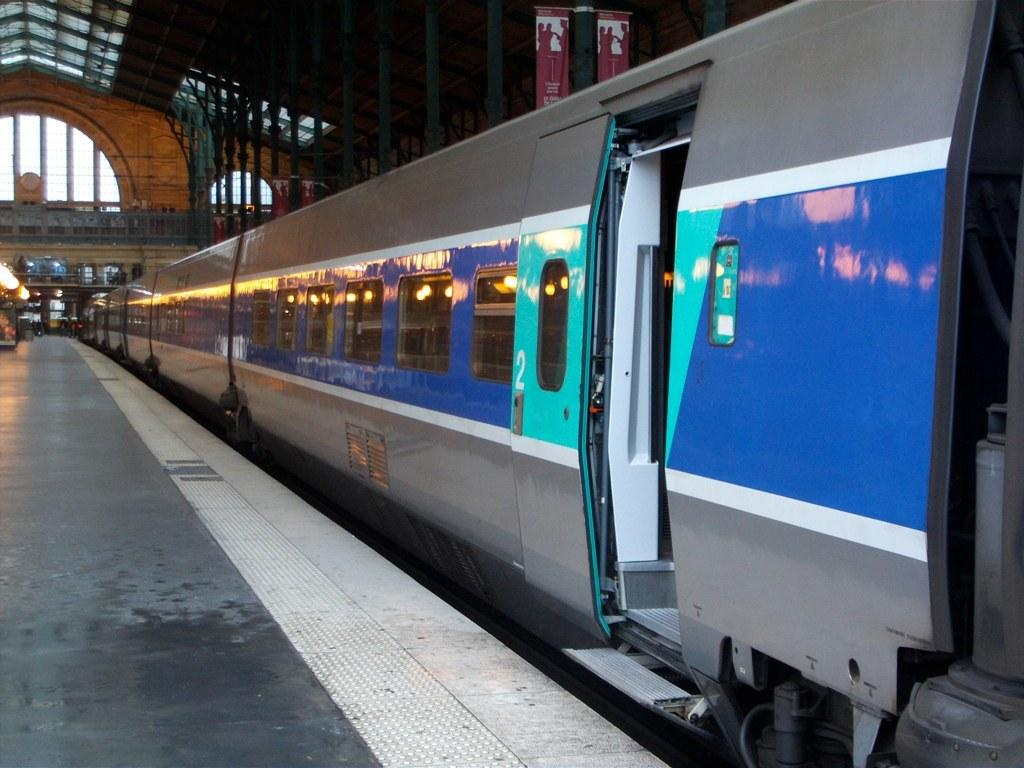What type of train is in the image? There is a silver and blue color train in the image. Where is the train located in the image? The train is waiting at a station. What can be seen above the train in the image? There is a metal shed ceiling visible in the image. What is hanging from the metal shed ceiling? A roller poster is hanging from the metal shed ceiling. What degree of drainage is required for the cellar in the image? There is no cellar present in the image, so it is not possible to determine the degree of drainage required. 